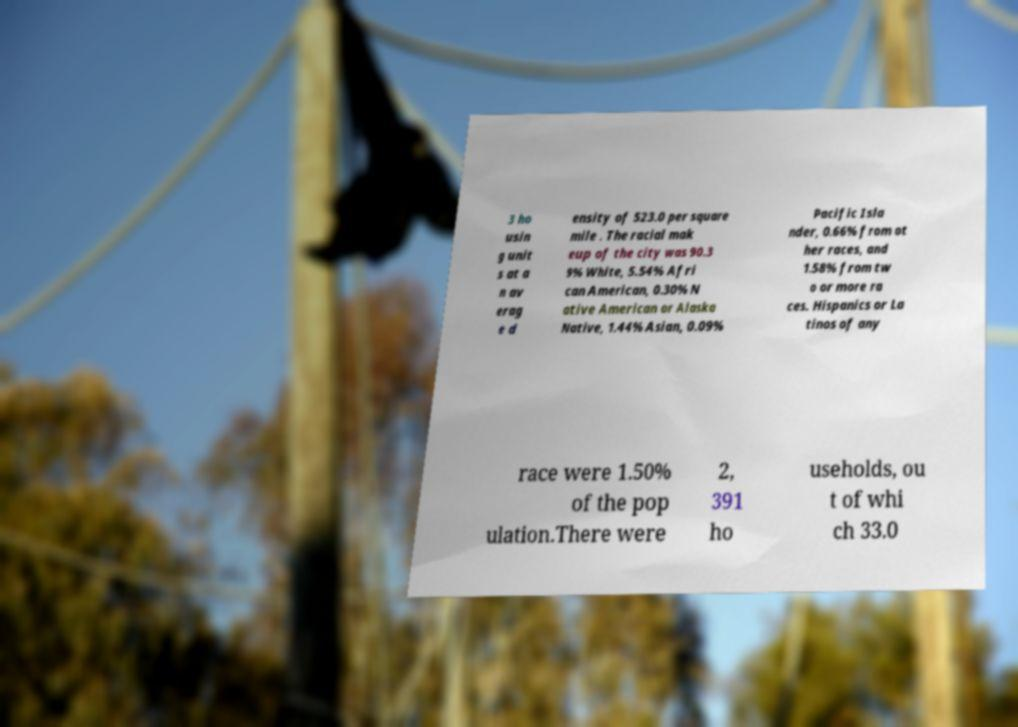Could you extract and type out the text from this image? 3 ho usin g unit s at a n av erag e d ensity of 523.0 per square mile . The racial mak eup of the city was 90.3 9% White, 5.54% Afri can American, 0.30% N ative American or Alaska Native, 1.44% Asian, 0.09% Pacific Isla nder, 0.66% from ot her races, and 1.58% from tw o or more ra ces. Hispanics or La tinos of any race were 1.50% of the pop ulation.There were 2, 391 ho useholds, ou t of whi ch 33.0 